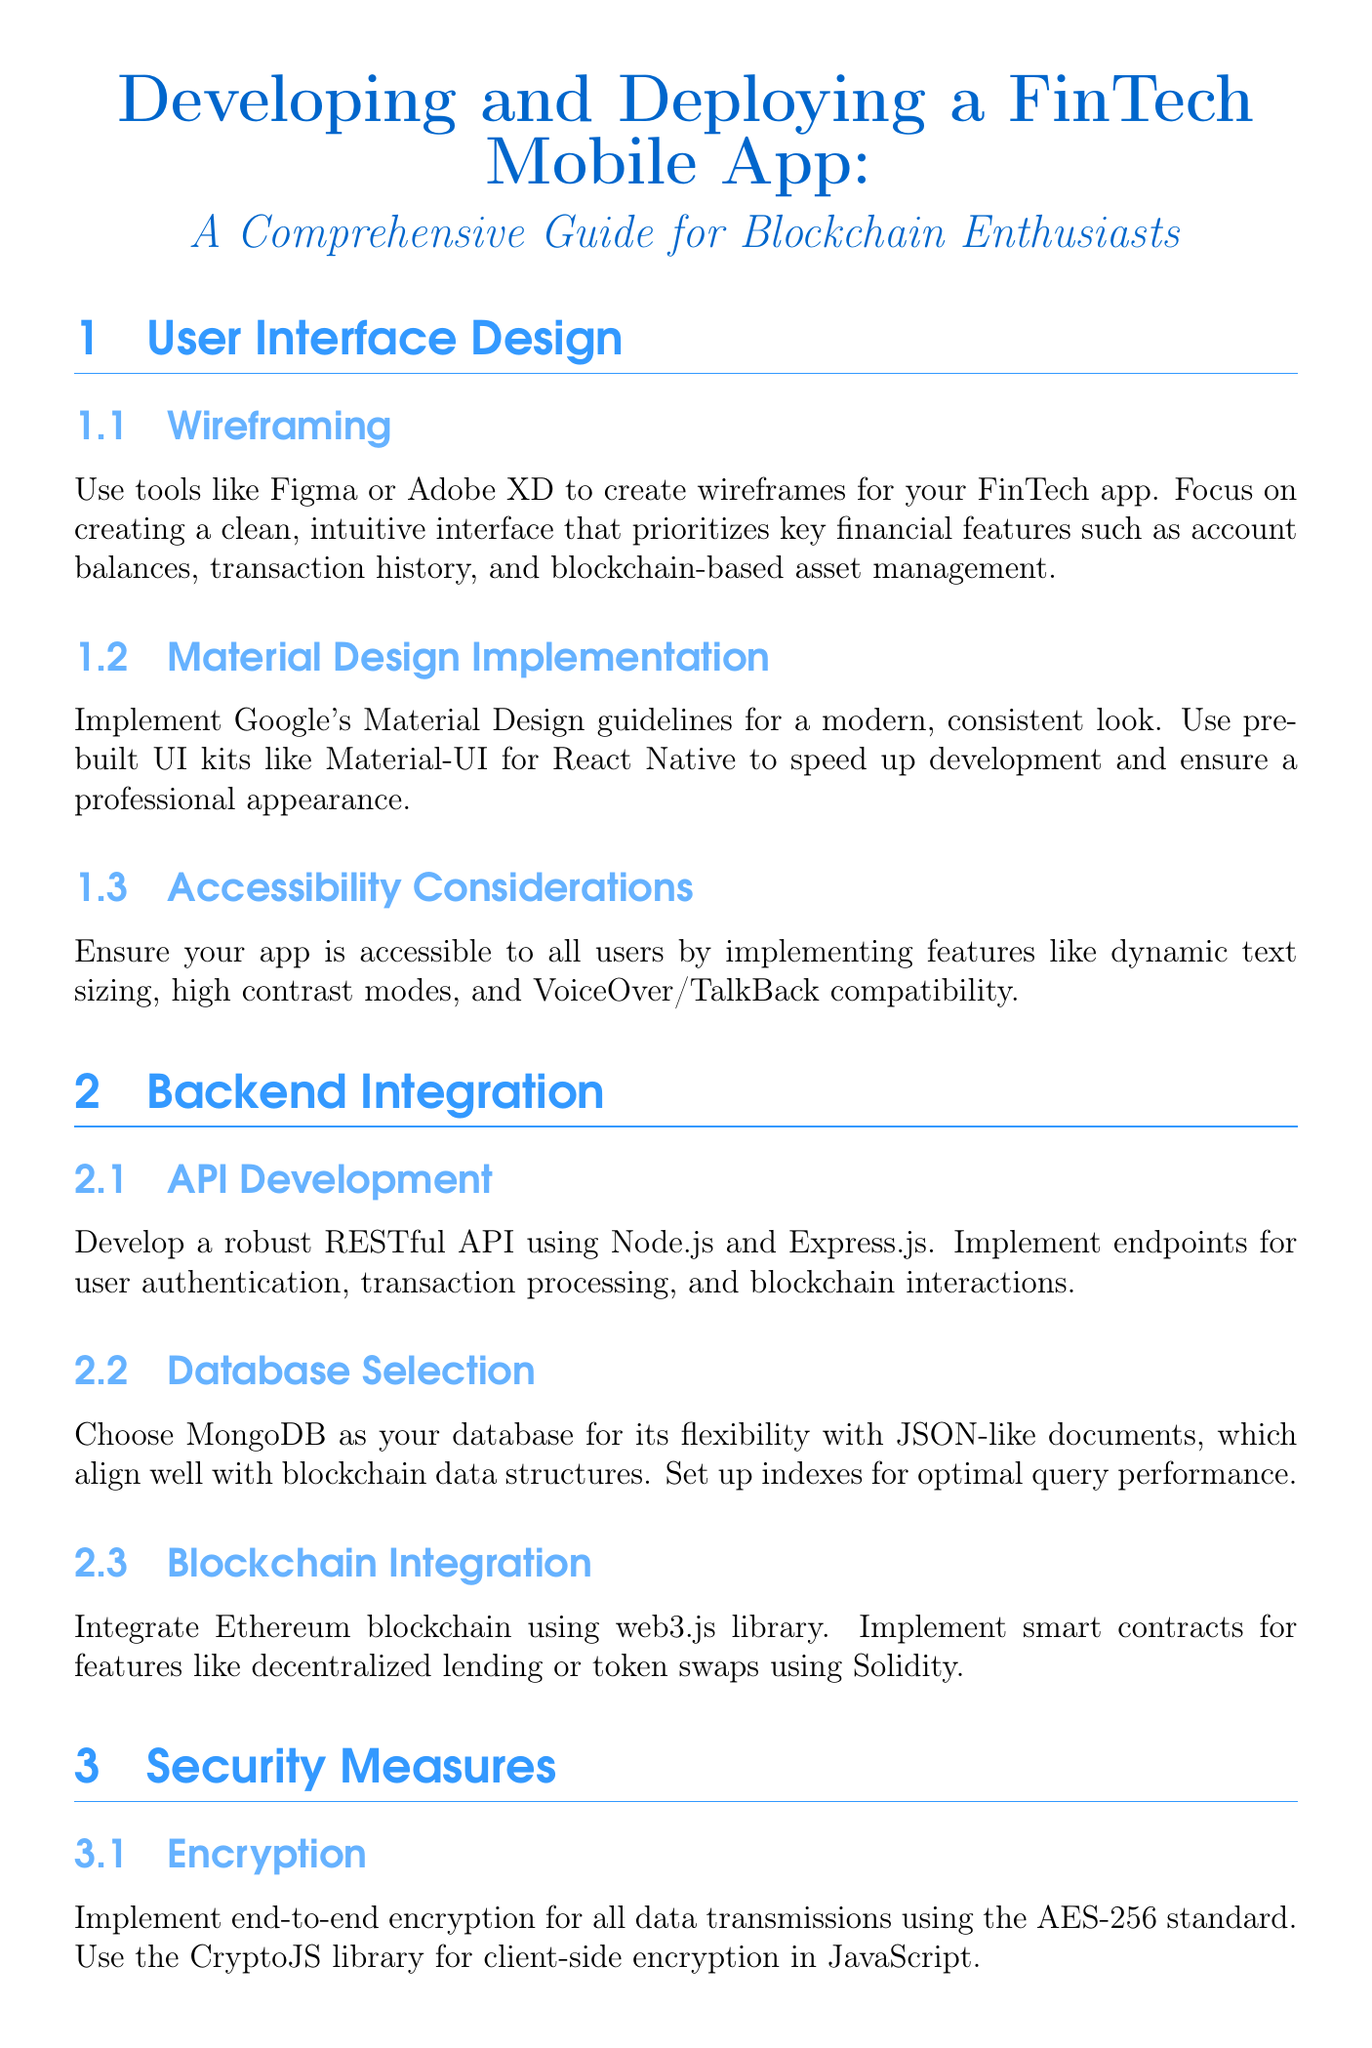What tools are recommended for wireframing? The document mentions using Figma or Adobe XD for creating wireframes for the FinTech app.
Answer: Figma, Adobe XD Which database is suggested for backend integration? The document recommends MongoDB for its flexibility with JSON-like documents.
Answer: MongoDB What encryption standard is advised for data transmissions? The document states to implement end-to-end encryption using the AES-256 standard.
Answer: AES-256 How many users are recommended for closed beta testing? The guide suggests conducting a closed beta test with 50-100 users.
Answer: 50-100 What library is recommended for client-side encryption? The document specifies using the CryptoJS library for client-side encryption.
Answer: CryptoJS What user interface design framework should be implemented for a modern look? The document advises implementing Google's Material Design guidelines for a modern appearance.
Answer: Material Design What technology is suggested for blockchain integration? The document recommends integrating Ethereum blockchain using the web3.js library.
Answer: web3.js What feature is emphasized for accessibility? The document highlights dynamic text sizing as an important accessibility feature.
Answer: Dynamic text sizing What type of testing should achieve at least 80% code coverage? The document specifies that unit testing should aim for at least 80% code coverage.
Answer: Unit testing 